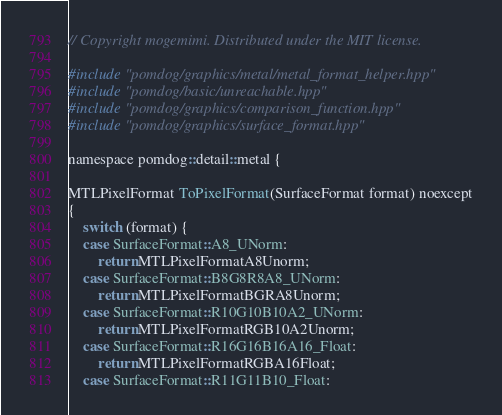<code> <loc_0><loc_0><loc_500><loc_500><_ObjectiveC_>// Copyright mogemimi. Distributed under the MIT license.

#include "pomdog/graphics/metal/metal_format_helper.hpp"
#include "pomdog/basic/unreachable.hpp"
#include "pomdog/graphics/comparison_function.hpp"
#include "pomdog/graphics/surface_format.hpp"

namespace pomdog::detail::metal {

MTLPixelFormat ToPixelFormat(SurfaceFormat format) noexcept
{
    switch (format) {
    case SurfaceFormat::A8_UNorm:
        return MTLPixelFormatA8Unorm;
    case SurfaceFormat::B8G8R8A8_UNorm:
        return MTLPixelFormatBGRA8Unorm;
    case SurfaceFormat::R10G10B10A2_UNorm:
        return MTLPixelFormatRGB10A2Unorm;
    case SurfaceFormat::R16G16B16A16_Float:
        return MTLPixelFormatRGBA16Float;
    case SurfaceFormat::R11G11B10_Float:</code> 